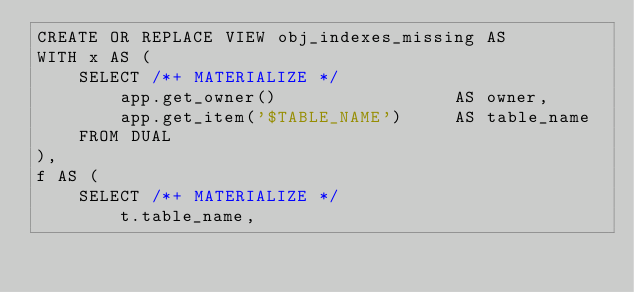Convert code to text. <code><loc_0><loc_0><loc_500><loc_500><_SQL_>CREATE OR REPLACE VIEW obj_indexes_missing AS
WITH x AS (
    SELECT /*+ MATERIALIZE */
        app.get_owner()                 AS owner,
        app.get_item('$TABLE_NAME')     AS table_name
    FROM DUAL
),
f AS (
    SELECT /*+ MATERIALIZE */
        t.table_name,</code> 